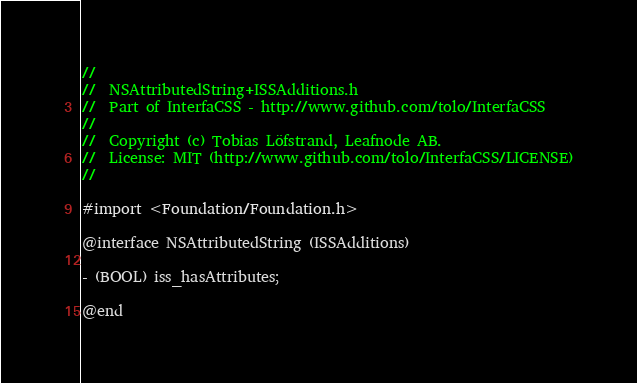<code> <loc_0><loc_0><loc_500><loc_500><_C_>//
//  NSAttributedString+ISSAdditions.h
//  Part of InterfaCSS - http://www.github.com/tolo/InterfaCSS
//
//  Copyright (c) Tobias Löfstrand, Leafnode AB.
//  License: MIT (http://www.github.com/tolo/InterfaCSS/LICENSE)
//

#import <Foundation/Foundation.h>

@interface NSAttributedString (ISSAdditions)

- (BOOL) iss_hasAttributes;

@end</code> 